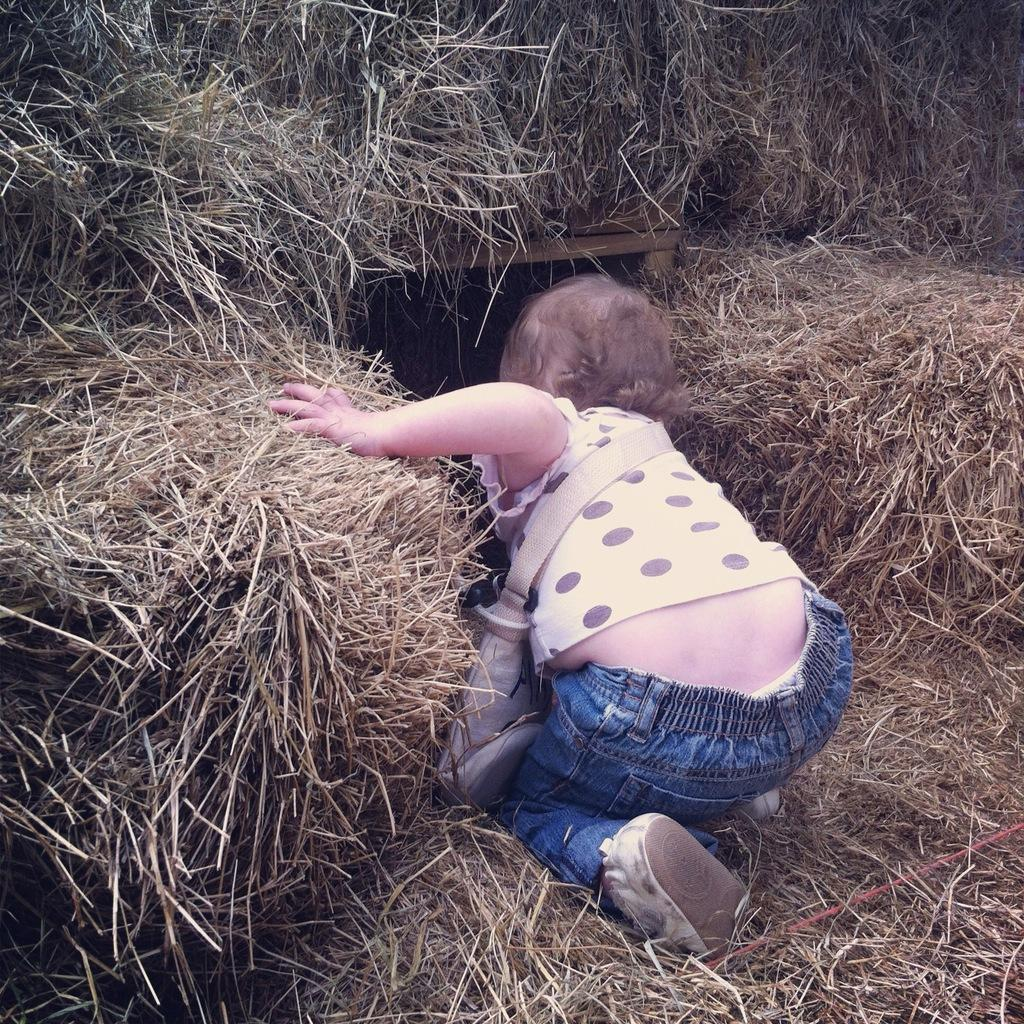What is the main subject in the center of the image? There is dry grass in the center of the image. What is the girl doing in the image? The girl is sitting in the dry grass. What is the girl wearing on her upper body? The girl is wearing a black and white top. What is the girl carrying in the image? The girl is wearing a bag. What type of voice can be heard coming from the girl in the image? There is no indication of any sound or voice in the image, so it cannot be determined. 